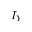Convert formula to latex. <formula><loc_0><loc_0><loc_500><loc_500>I _ { Y }</formula> 